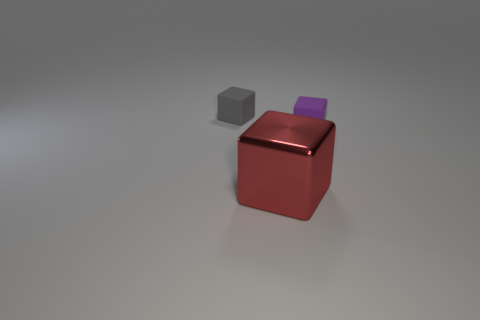Are there any other things that have the same color as the large cube?
Provide a short and direct response. No. What is the size of the cube that is left of the purple object and behind the metal cube?
Give a very brief answer. Small. There is a matte object that is in front of the gray matte object; is its color the same as the tiny block on the left side of the big red object?
Offer a terse response. No. How many other things are the same material as the purple object?
Your answer should be compact. 1. What is the shape of the thing that is behind the red shiny thing and left of the tiny purple cube?
Provide a succinct answer. Cube. There is a large metal object; is its color the same as the tiny cube in front of the small gray rubber thing?
Keep it short and to the point. No. Does the thing that is left of the red cube have the same size as the purple thing?
Your answer should be compact. Yes. What material is the tiny purple object that is the same shape as the red shiny object?
Offer a terse response. Rubber. Does the large metal object have the same shape as the tiny purple thing?
Give a very brief answer. Yes. There is a tiny gray block behind the purple rubber thing; what number of purple things are in front of it?
Provide a short and direct response. 1. 